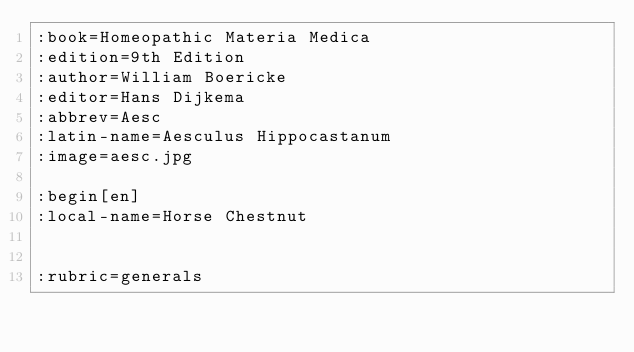<code> <loc_0><loc_0><loc_500><loc_500><_ObjectiveC_>:book=Homeopathic Materia Medica
:edition=9th Edition
:author=William Boericke
:editor=Hans Dijkema
:abbrev=Aesc
:latin-name=Aesculus Hippocastanum
:image=aesc.jpg

:begin[en]
:local-name=Horse Chestnut


:rubric=generals</code> 